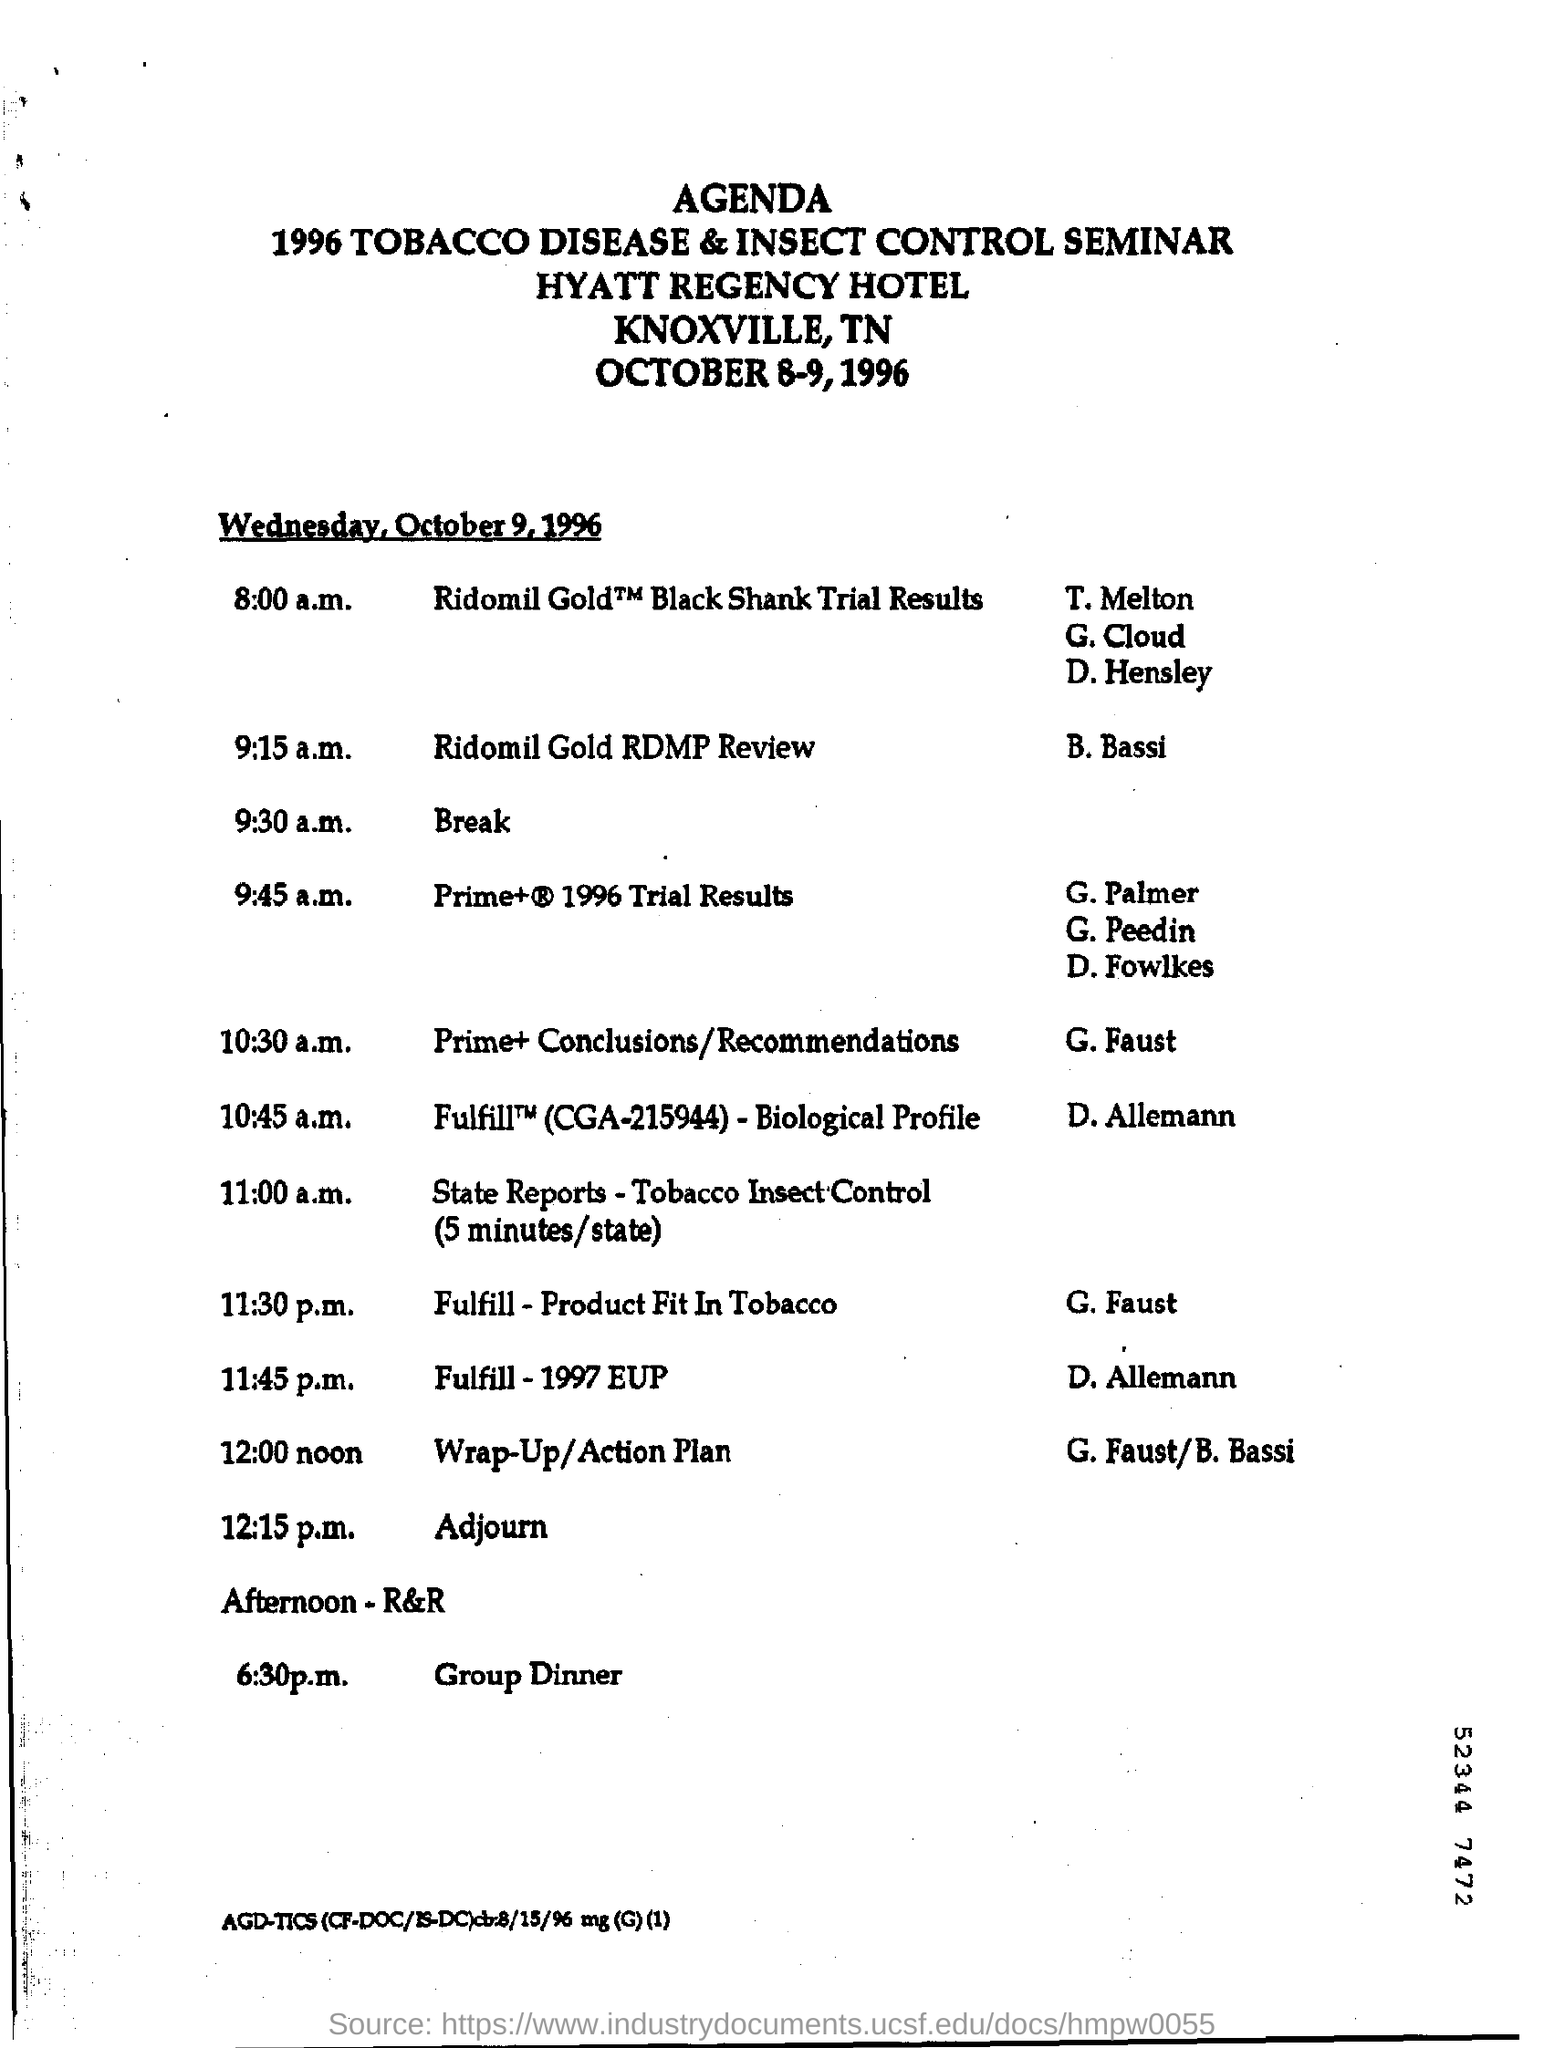What is the time of break for 1996 tobacco disease & insect control seminar?
Give a very brief answer. 9:30 a.m. 